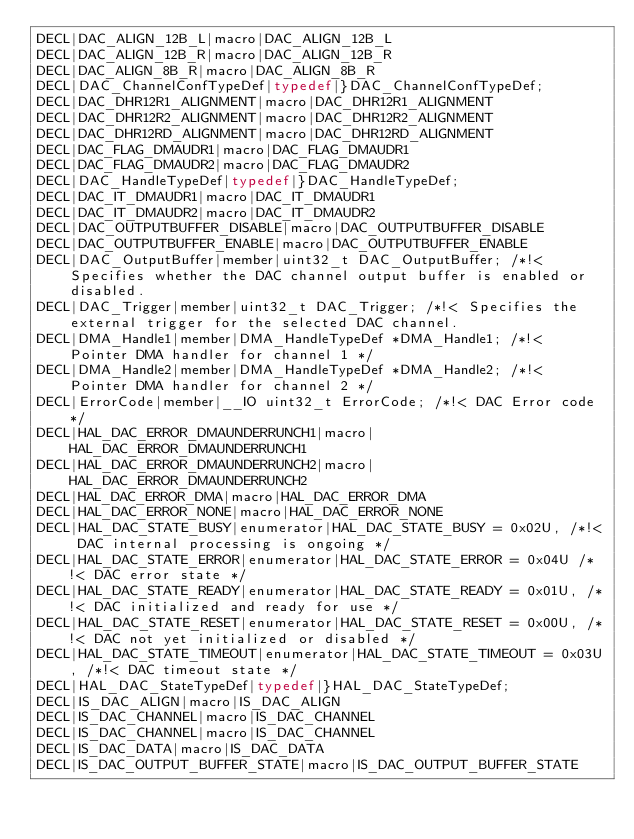Convert code to text. <code><loc_0><loc_0><loc_500><loc_500><_C_>DECL|DAC_ALIGN_12B_L|macro|DAC_ALIGN_12B_L
DECL|DAC_ALIGN_12B_R|macro|DAC_ALIGN_12B_R
DECL|DAC_ALIGN_8B_R|macro|DAC_ALIGN_8B_R
DECL|DAC_ChannelConfTypeDef|typedef|}DAC_ChannelConfTypeDef;
DECL|DAC_DHR12R1_ALIGNMENT|macro|DAC_DHR12R1_ALIGNMENT
DECL|DAC_DHR12R2_ALIGNMENT|macro|DAC_DHR12R2_ALIGNMENT
DECL|DAC_DHR12RD_ALIGNMENT|macro|DAC_DHR12RD_ALIGNMENT
DECL|DAC_FLAG_DMAUDR1|macro|DAC_FLAG_DMAUDR1
DECL|DAC_FLAG_DMAUDR2|macro|DAC_FLAG_DMAUDR2
DECL|DAC_HandleTypeDef|typedef|}DAC_HandleTypeDef;
DECL|DAC_IT_DMAUDR1|macro|DAC_IT_DMAUDR1
DECL|DAC_IT_DMAUDR2|macro|DAC_IT_DMAUDR2
DECL|DAC_OUTPUTBUFFER_DISABLE|macro|DAC_OUTPUTBUFFER_DISABLE
DECL|DAC_OUTPUTBUFFER_ENABLE|macro|DAC_OUTPUTBUFFER_ENABLE
DECL|DAC_OutputBuffer|member|uint32_t DAC_OutputBuffer; /*!< Specifies whether the DAC channel output buffer is enabled or disabled.
DECL|DAC_Trigger|member|uint32_t DAC_Trigger; /*!< Specifies the external trigger for the selected DAC channel.
DECL|DMA_Handle1|member|DMA_HandleTypeDef *DMA_Handle1; /*!< Pointer DMA handler for channel 1 */
DECL|DMA_Handle2|member|DMA_HandleTypeDef *DMA_Handle2; /*!< Pointer DMA handler for channel 2 */
DECL|ErrorCode|member|__IO uint32_t ErrorCode; /*!< DAC Error code */
DECL|HAL_DAC_ERROR_DMAUNDERRUNCH1|macro|HAL_DAC_ERROR_DMAUNDERRUNCH1
DECL|HAL_DAC_ERROR_DMAUNDERRUNCH2|macro|HAL_DAC_ERROR_DMAUNDERRUNCH2
DECL|HAL_DAC_ERROR_DMA|macro|HAL_DAC_ERROR_DMA
DECL|HAL_DAC_ERROR_NONE|macro|HAL_DAC_ERROR_NONE
DECL|HAL_DAC_STATE_BUSY|enumerator|HAL_DAC_STATE_BUSY = 0x02U, /*!< DAC internal processing is ongoing */
DECL|HAL_DAC_STATE_ERROR|enumerator|HAL_DAC_STATE_ERROR = 0x04U /*!< DAC error state */
DECL|HAL_DAC_STATE_READY|enumerator|HAL_DAC_STATE_READY = 0x01U, /*!< DAC initialized and ready for use */
DECL|HAL_DAC_STATE_RESET|enumerator|HAL_DAC_STATE_RESET = 0x00U, /*!< DAC not yet initialized or disabled */
DECL|HAL_DAC_STATE_TIMEOUT|enumerator|HAL_DAC_STATE_TIMEOUT = 0x03U, /*!< DAC timeout state */
DECL|HAL_DAC_StateTypeDef|typedef|}HAL_DAC_StateTypeDef;
DECL|IS_DAC_ALIGN|macro|IS_DAC_ALIGN
DECL|IS_DAC_CHANNEL|macro|IS_DAC_CHANNEL
DECL|IS_DAC_CHANNEL|macro|IS_DAC_CHANNEL
DECL|IS_DAC_DATA|macro|IS_DAC_DATA
DECL|IS_DAC_OUTPUT_BUFFER_STATE|macro|IS_DAC_OUTPUT_BUFFER_STATE</code> 